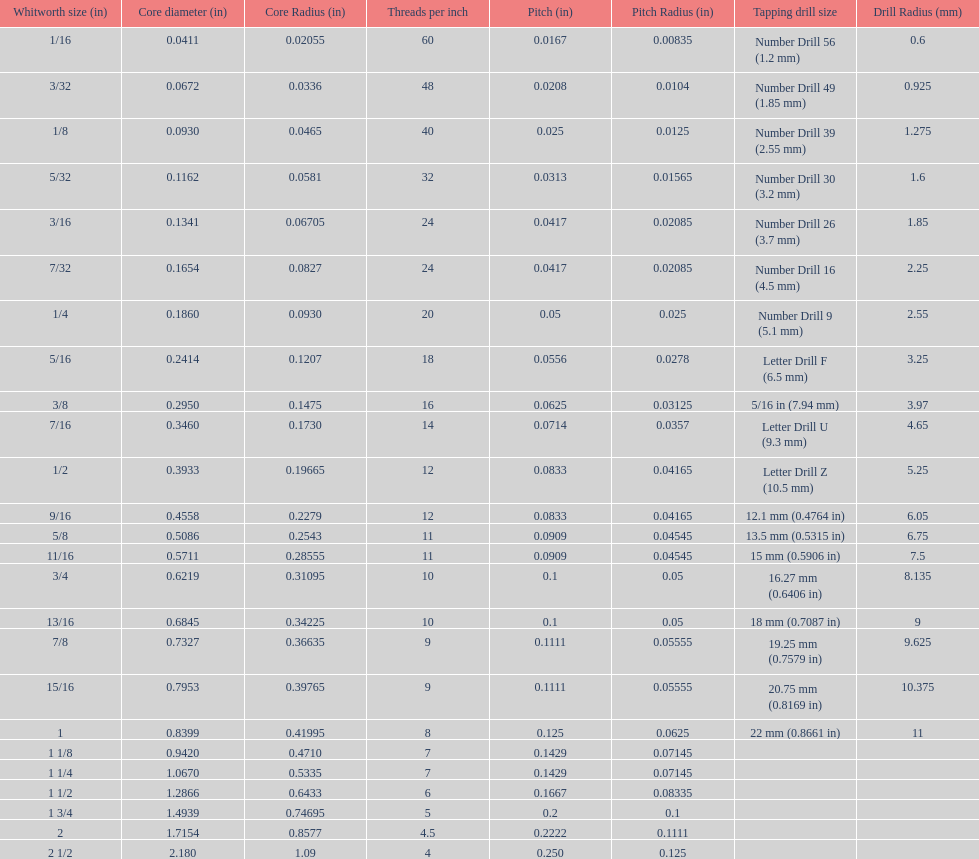How many more threads per inch does the 1/16th whitworth size have over the 1/8th whitworth size? 20. 